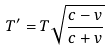<formula> <loc_0><loc_0><loc_500><loc_500>T ^ { \prime } = T \sqrt { \frac { c - v } { c + v } }</formula> 